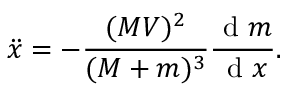<formula> <loc_0><loc_0><loc_500><loc_500>\ddot { x } = - \frac { ( M V ) ^ { 2 } } { ( M + m ) ^ { 3 } } \frac { d m } { d x } .</formula> 